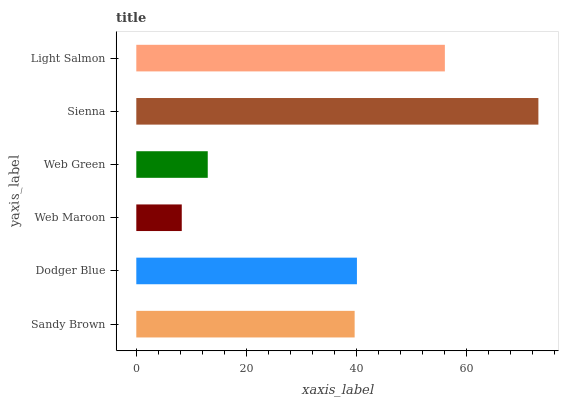Is Web Maroon the minimum?
Answer yes or no. Yes. Is Sienna the maximum?
Answer yes or no. Yes. Is Dodger Blue the minimum?
Answer yes or no. No. Is Dodger Blue the maximum?
Answer yes or no. No. Is Dodger Blue greater than Sandy Brown?
Answer yes or no. Yes. Is Sandy Brown less than Dodger Blue?
Answer yes or no. Yes. Is Sandy Brown greater than Dodger Blue?
Answer yes or no. No. Is Dodger Blue less than Sandy Brown?
Answer yes or no. No. Is Dodger Blue the high median?
Answer yes or no. Yes. Is Sandy Brown the low median?
Answer yes or no. Yes. Is Sandy Brown the high median?
Answer yes or no. No. Is Web Maroon the low median?
Answer yes or no. No. 